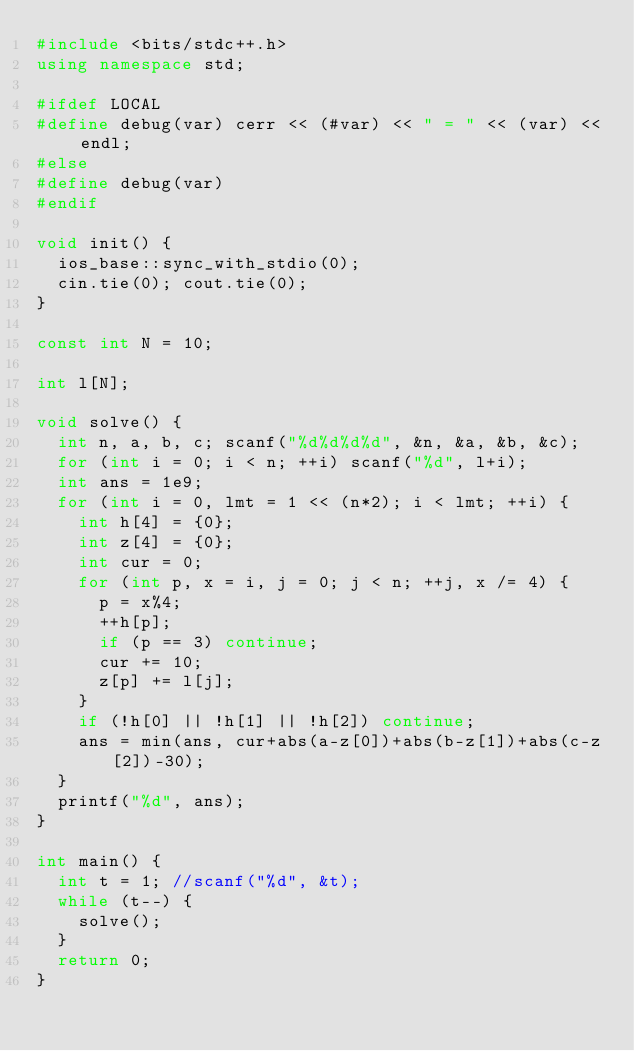<code> <loc_0><loc_0><loc_500><loc_500><_C++_>#include <bits/stdc++.h>
using namespace std;

#ifdef LOCAL
#define debug(var) cerr << (#var) << " = " << (var) << endl;
#else
#define debug(var)
#endif

void init() {
  ios_base::sync_with_stdio(0);
  cin.tie(0); cout.tie(0);
}

const int N = 10;

int l[N];

void solve() {
  int n, a, b, c; scanf("%d%d%d%d", &n, &a, &b, &c);
  for (int i = 0; i < n; ++i) scanf("%d", l+i);
  int ans = 1e9;
  for (int i = 0, lmt = 1 << (n*2); i < lmt; ++i) {
    int h[4] = {0};
    int z[4] = {0};
    int cur = 0;
    for (int p, x = i, j = 0; j < n; ++j, x /= 4) {
      p = x%4;
      ++h[p];
      if (p == 3) continue;
      cur += 10;
      z[p] += l[j];
    }
    if (!h[0] || !h[1] || !h[2]) continue;
    ans = min(ans, cur+abs(a-z[0])+abs(b-z[1])+abs(c-z[2])-30);
  }
  printf("%d", ans);
}

int main() {
  int t = 1; //scanf("%d", &t);
  while (t--) {
    solve();
  }
  return 0;
}
</code> 